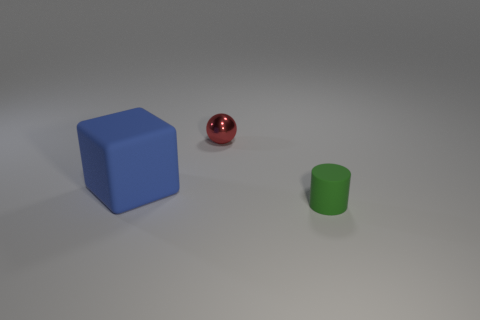Add 1 small gray cylinders. How many objects exist? 4 Subtract 1 spheres. How many spheres are left? 0 Subtract all spheres. How many objects are left? 2 Subtract all cyan cubes. Subtract all red spheres. How many cubes are left? 1 Subtract all tiny metal balls. Subtract all metallic spheres. How many objects are left? 1 Add 1 small green cylinders. How many small green cylinders are left? 2 Add 1 green objects. How many green objects exist? 2 Subtract 0 green balls. How many objects are left? 3 